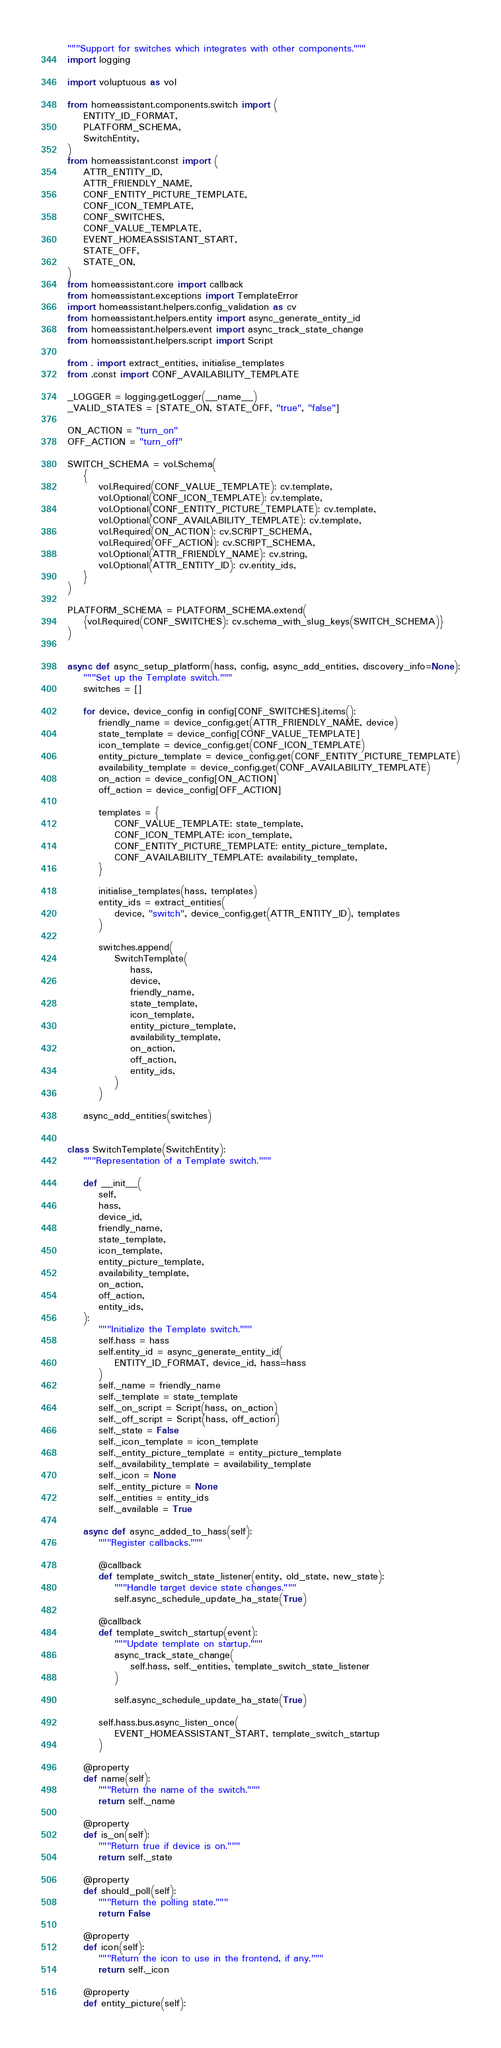<code> <loc_0><loc_0><loc_500><loc_500><_Python_>"""Support for switches which integrates with other components."""
import logging

import voluptuous as vol

from homeassistant.components.switch import (
    ENTITY_ID_FORMAT,
    PLATFORM_SCHEMA,
    SwitchEntity,
)
from homeassistant.const import (
    ATTR_ENTITY_ID,
    ATTR_FRIENDLY_NAME,
    CONF_ENTITY_PICTURE_TEMPLATE,
    CONF_ICON_TEMPLATE,
    CONF_SWITCHES,
    CONF_VALUE_TEMPLATE,
    EVENT_HOMEASSISTANT_START,
    STATE_OFF,
    STATE_ON,
)
from homeassistant.core import callback
from homeassistant.exceptions import TemplateError
import homeassistant.helpers.config_validation as cv
from homeassistant.helpers.entity import async_generate_entity_id
from homeassistant.helpers.event import async_track_state_change
from homeassistant.helpers.script import Script

from . import extract_entities, initialise_templates
from .const import CONF_AVAILABILITY_TEMPLATE

_LOGGER = logging.getLogger(__name__)
_VALID_STATES = [STATE_ON, STATE_OFF, "true", "false"]

ON_ACTION = "turn_on"
OFF_ACTION = "turn_off"

SWITCH_SCHEMA = vol.Schema(
    {
        vol.Required(CONF_VALUE_TEMPLATE): cv.template,
        vol.Optional(CONF_ICON_TEMPLATE): cv.template,
        vol.Optional(CONF_ENTITY_PICTURE_TEMPLATE): cv.template,
        vol.Optional(CONF_AVAILABILITY_TEMPLATE): cv.template,
        vol.Required(ON_ACTION): cv.SCRIPT_SCHEMA,
        vol.Required(OFF_ACTION): cv.SCRIPT_SCHEMA,
        vol.Optional(ATTR_FRIENDLY_NAME): cv.string,
        vol.Optional(ATTR_ENTITY_ID): cv.entity_ids,
    }
)

PLATFORM_SCHEMA = PLATFORM_SCHEMA.extend(
    {vol.Required(CONF_SWITCHES): cv.schema_with_slug_keys(SWITCH_SCHEMA)}
)


async def async_setup_platform(hass, config, async_add_entities, discovery_info=None):
    """Set up the Template switch."""
    switches = []

    for device, device_config in config[CONF_SWITCHES].items():
        friendly_name = device_config.get(ATTR_FRIENDLY_NAME, device)
        state_template = device_config[CONF_VALUE_TEMPLATE]
        icon_template = device_config.get(CONF_ICON_TEMPLATE)
        entity_picture_template = device_config.get(CONF_ENTITY_PICTURE_TEMPLATE)
        availability_template = device_config.get(CONF_AVAILABILITY_TEMPLATE)
        on_action = device_config[ON_ACTION]
        off_action = device_config[OFF_ACTION]

        templates = {
            CONF_VALUE_TEMPLATE: state_template,
            CONF_ICON_TEMPLATE: icon_template,
            CONF_ENTITY_PICTURE_TEMPLATE: entity_picture_template,
            CONF_AVAILABILITY_TEMPLATE: availability_template,
        }

        initialise_templates(hass, templates)
        entity_ids = extract_entities(
            device, "switch", device_config.get(ATTR_ENTITY_ID), templates
        )

        switches.append(
            SwitchTemplate(
                hass,
                device,
                friendly_name,
                state_template,
                icon_template,
                entity_picture_template,
                availability_template,
                on_action,
                off_action,
                entity_ids,
            )
        )

    async_add_entities(switches)


class SwitchTemplate(SwitchEntity):
    """Representation of a Template switch."""

    def __init__(
        self,
        hass,
        device_id,
        friendly_name,
        state_template,
        icon_template,
        entity_picture_template,
        availability_template,
        on_action,
        off_action,
        entity_ids,
    ):
        """Initialize the Template switch."""
        self.hass = hass
        self.entity_id = async_generate_entity_id(
            ENTITY_ID_FORMAT, device_id, hass=hass
        )
        self._name = friendly_name
        self._template = state_template
        self._on_script = Script(hass, on_action)
        self._off_script = Script(hass, off_action)
        self._state = False
        self._icon_template = icon_template
        self._entity_picture_template = entity_picture_template
        self._availability_template = availability_template
        self._icon = None
        self._entity_picture = None
        self._entities = entity_ids
        self._available = True

    async def async_added_to_hass(self):
        """Register callbacks."""

        @callback
        def template_switch_state_listener(entity, old_state, new_state):
            """Handle target device state changes."""
            self.async_schedule_update_ha_state(True)

        @callback
        def template_switch_startup(event):
            """Update template on startup."""
            async_track_state_change(
                self.hass, self._entities, template_switch_state_listener
            )

            self.async_schedule_update_ha_state(True)

        self.hass.bus.async_listen_once(
            EVENT_HOMEASSISTANT_START, template_switch_startup
        )

    @property
    def name(self):
        """Return the name of the switch."""
        return self._name

    @property
    def is_on(self):
        """Return true if device is on."""
        return self._state

    @property
    def should_poll(self):
        """Return the polling state."""
        return False

    @property
    def icon(self):
        """Return the icon to use in the frontend, if any."""
        return self._icon

    @property
    def entity_picture(self):</code> 